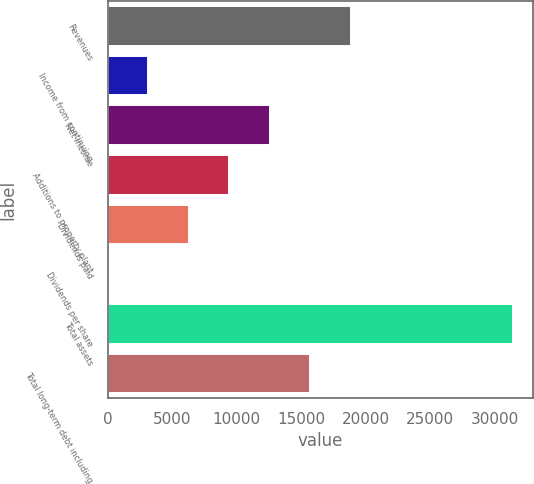Convert chart. <chart><loc_0><loc_0><loc_500><loc_500><bar_chart><fcel>Revenues<fcel>Income from continuing<fcel>Net income<fcel>Additions to property plant<fcel>Dividends paid<fcel>Dividends per share<fcel>Total assets<fcel>Total long-term debt including<nl><fcel>18822.9<fcel>3137.82<fcel>12548.9<fcel>9411.86<fcel>6274.84<fcel>0.8<fcel>31371<fcel>15685.9<nl></chart> 